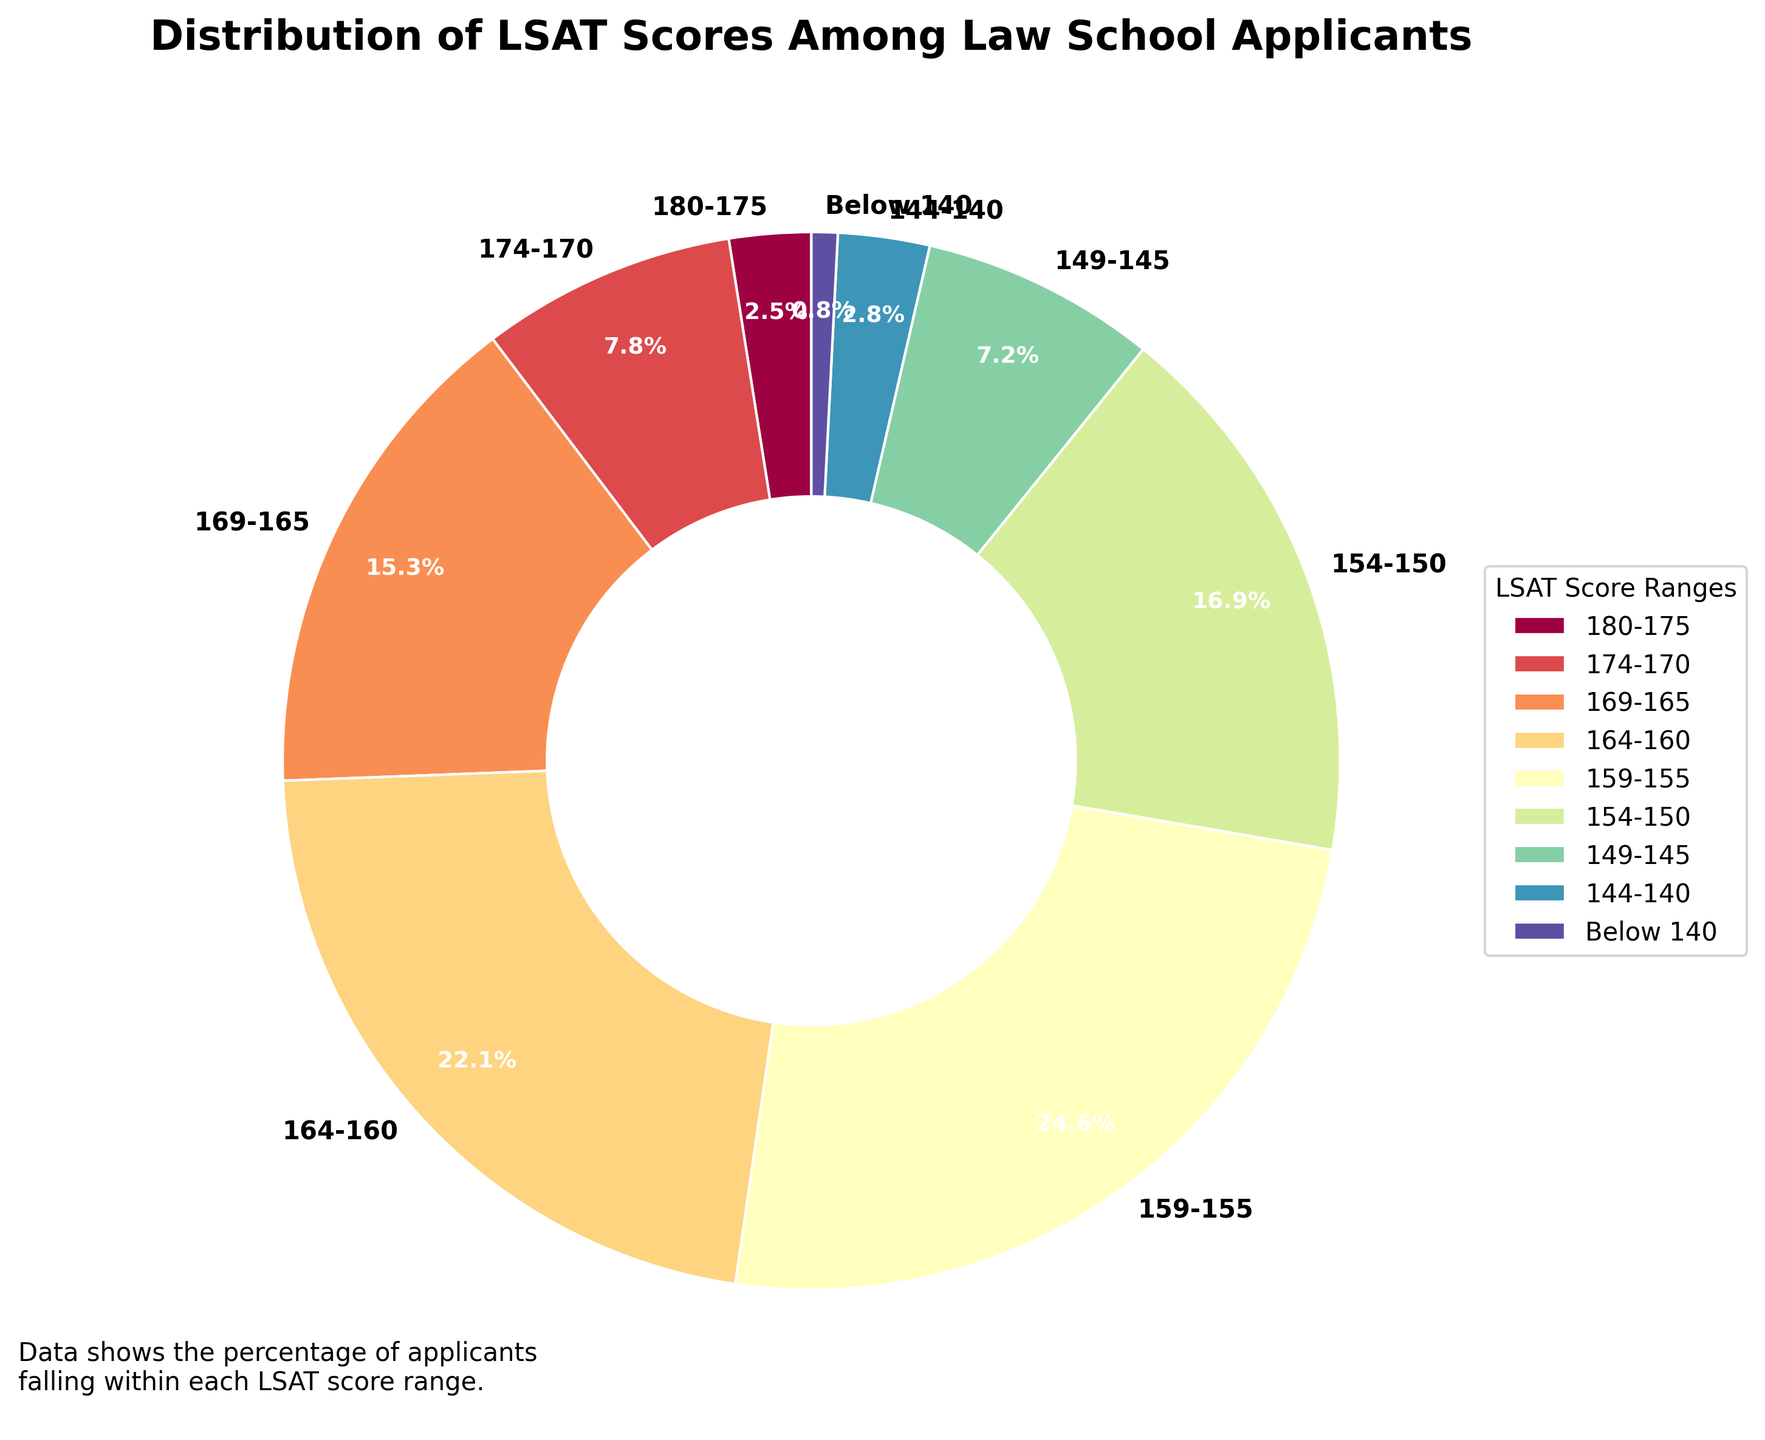What LSAT score range has the highest percentage of applicants? To find the LSAT score range with the highest percentage, look at the pie chart segments and see which one is largest. The segment labeled "159-155" covers the largest area, indicating it has the highest percentage of applicants at 24.6%.
Answer: 159-155 What percentage of applicants scored between 154 and 160? To determine the percentage of applicants scoring between 154 and 160, sum up the percentages for the relevant ranges: 154-150 (16.9%) and 159-155 (24.6%). 16.9% + 24.6% = 41.5%.
Answer: 41.5% Which LSAT score range has a very similar percentage of applicants to the 144-140 range? Look at the pie chart and compare the "144-140" (2.8%) segment with other similar-sized segments. The segment "180-175" has a very close percentage of 2.5%.
Answer: 180-175 How many LSAT score ranges have a percentage of applicants above 10%? Examine the pie chart and identify how many segments have percentages greater than 10%: "164-160" (22.1%), "159-155" (24.6%), and "169-165" (15.3%). This gives 3 ranges above 10%.
Answer: 3 What is the combined percentage of applicants who scored below 150? Sum the percentages of the relevant ranges: "149-145" (7.2%), "144-140" (2.8%), and "Below 140" (0.8%). 7.2% + 2.8% + 0.8% = 10.8%.
Answer: 10.8% Is there a significant drop in the percentage of applicants after the most common score range? Identify the most common score range ("159-155" at 24.6%) and compare it to the next largest range ("164-160" at 22.1%). The drop is 24.6% - 22.1% = 2.5%, which is not significant.
Answer: No Which two adjacent LSAT score ranges have the smallest difference in their percentage of applicants? Compare percentages of adjacent ranges: 164-160 (22.1%) and 169-165 (15.3%) have the smallest difference: 22.1% - 15.3% = 6.8%.
Answer: 164-160 and 169-165 Does the percentage of applicants gradually decrease or show fluctuations in LSAT score distributions? Observe the pie chart segments to see if the percentages gradually decrease or fluctuate. The distribution shows fluctuations, for example, there's an increase from "174-170" (7.8%) to "159-155" (24.6%).
Answer: Fluctuations What portion of the applicants scored 165 or above? Add the percentages for the ranges: "180-175" (2.5%), "174-170" (7.8%), and "169-165" (15.3%). 2.5% + 7.8% + 15.3% = 25.6%.
Answer: 25.6% 